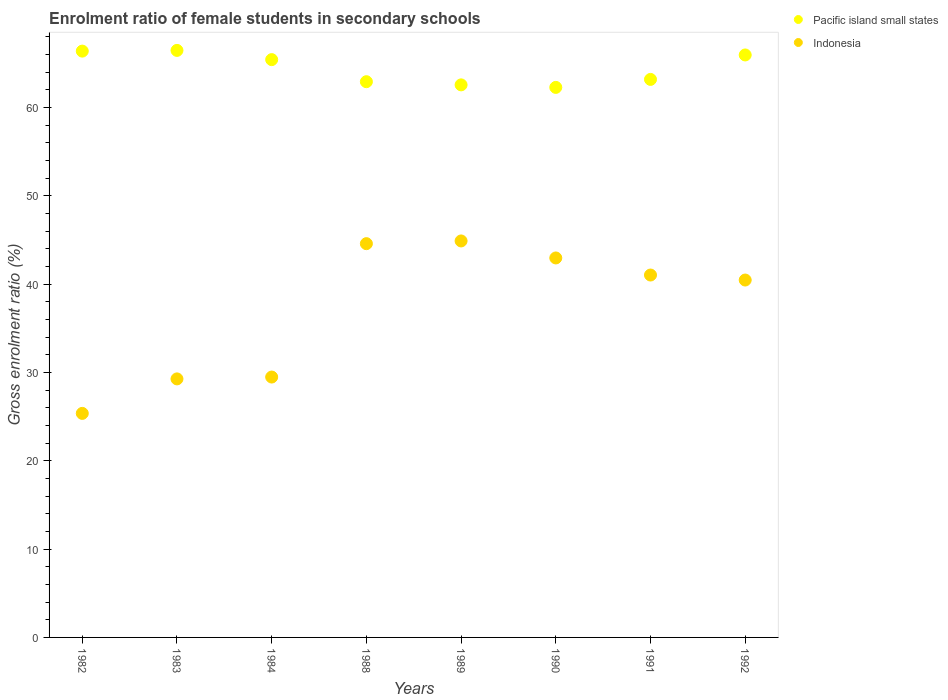How many different coloured dotlines are there?
Your response must be concise. 2. What is the enrolment ratio of female students in secondary schools in Indonesia in 1984?
Keep it short and to the point. 29.48. Across all years, what is the maximum enrolment ratio of female students in secondary schools in Pacific island small states?
Make the answer very short. 66.47. Across all years, what is the minimum enrolment ratio of female students in secondary schools in Pacific island small states?
Your answer should be very brief. 62.28. What is the total enrolment ratio of female students in secondary schools in Indonesia in the graph?
Provide a short and direct response. 298.09. What is the difference between the enrolment ratio of female students in secondary schools in Pacific island small states in 1984 and that in 1992?
Your response must be concise. -0.53. What is the difference between the enrolment ratio of female students in secondary schools in Pacific island small states in 1990 and the enrolment ratio of female students in secondary schools in Indonesia in 1982?
Provide a succinct answer. 36.91. What is the average enrolment ratio of female students in secondary schools in Indonesia per year?
Give a very brief answer. 37.26. In the year 1992, what is the difference between the enrolment ratio of female students in secondary schools in Pacific island small states and enrolment ratio of female students in secondary schools in Indonesia?
Give a very brief answer. 25.49. In how many years, is the enrolment ratio of female students in secondary schools in Indonesia greater than 38 %?
Your response must be concise. 5. What is the ratio of the enrolment ratio of female students in secondary schools in Pacific island small states in 1984 to that in 1989?
Ensure brevity in your answer.  1.05. Is the difference between the enrolment ratio of female students in secondary schools in Pacific island small states in 1990 and 1991 greater than the difference between the enrolment ratio of female students in secondary schools in Indonesia in 1990 and 1991?
Ensure brevity in your answer.  No. What is the difference between the highest and the second highest enrolment ratio of female students in secondary schools in Indonesia?
Ensure brevity in your answer.  0.31. What is the difference between the highest and the lowest enrolment ratio of female students in secondary schools in Pacific island small states?
Offer a very short reply. 4.19. Is the sum of the enrolment ratio of female students in secondary schools in Pacific island small states in 1991 and 1992 greater than the maximum enrolment ratio of female students in secondary schools in Indonesia across all years?
Offer a terse response. Yes. Is the enrolment ratio of female students in secondary schools in Indonesia strictly less than the enrolment ratio of female students in secondary schools in Pacific island small states over the years?
Keep it short and to the point. Yes. How many dotlines are there?
Provide a short and direct response. 2. How many years are there in the graph?
Keep it short and to the point. 8. What is the difference between two consecutive major ticks on the Y-axis?
Offer a very short reply. 10. Does the graph contain grids?
Your response must be concise. No. Where does the legend appear in the graph?
Provide a short and direct response. Top right. How many legend labels are there?
Offer a terse response. 2. What is the title of the graph?
Your answer should be compact. Enrolment ratio of female students in secondary schools. What is the label or title of the X-axis?
Your answer should be very brief. Years. What is the Gross enrolment ratio (%) of Pacific island small states in 1982?
Provide a short and direct response. 66.39. What is the Gross enrolment ratio (%) in Indonesia in 1982?
Your answer should be compact. 25.37. What is the Gross enrolment ratio (%) in Pacific island small states in 1983?
Offer a very short reply. 66.47. What is the Gross enrolment ratio (%) of Indonesia in 1983?
Give a very brief answer. 29.27. What is the Gross enrolment ratio (%) of Pacific island small states in 1984?
Offer a terse response. 65.43. What is the Gross enrolment ratio (%) of Indonesia in 1984?
Provide a short and direct response. 29.48. What is the Gross enrolment ratio (%) of Pacific island small states in 1988?
Offer a terse response. 62.93. What is the Gross enrolment ratio (%) in Indonesia in 1988?
Give a very brief answer. 44.59. What is the Gross enrolment ratio (%) in Pacific island small states in 1989?
Your answer should be compact. 62.57. What is the Gross enrolment ratio (%) in Indonesia in 1989?
Provide a short and direct response. 44.9. What is the Gross enrolment ratio (%) of Pacific island small states in 1990?
Your answer should be compact. 62.28. What is the Gross enrolment ratio (%) in Indonesia in 1990?
Your answer should be compact. 42.97. What is the Gross enrolment ratio (%) of Pacific island small states in 1991?
Provide a short and direct response. 63.19. What is the Gross enrolment ratio (%) of Indonesia in 1991?
Your answer should be very brief. 41.04. What is the Gross enrolment ratio (%) in Pacific island small states in 1992?
Your answer should be very brief. 65.96. What is the Gross enrolment ratio (%) of Indonesia in 1992?
Provide a succinct answer. 40.47. Across all years, what is the maximum Gross enrolment ratio (%) of Pacific island small states?
Keep it short and to the point. 66.47. Across all years, what is the maximum Gross enrolment ratio (%) in Indonesia?
Ensure brevity in your answer.  44.9. Across all years, what is the minimum Gross enrolment ratio (%) of Pacific island small states?
Your answer should be compact. 62.28. Across all years, what is the minimum Gross enrolment ratio (%) in Indonesia?
Provide a succinct answer. 25.37. What is the total Gross enrolment ratio (%) of Pacific island small states in the graph?
Provide a short and direct response. 515.22. What is the total Gross enrolment ratio (%) in Indonesia in the graph?
Offer a terse response. 298.09. What is the difference between the Gross enrolment ratio (%) in Pacific island small states in 1982 and that in 1983?
Ensure brevity in your answer.  -0.08. What is the difference between the Gross enrolment ratio (%) in Indonesia in 1982 and that in 1983?
Offer a very short reply. -3.91. What is the difference between the Gross enrolment ratio (%) in Pacific island small states in 1982 and that in 1984?
Offer a very short reply. 0.96. What is the difference between the Gross enrolment ratio (%) in Indonesia in 1982 and that in 1984?
Make the answer very short. -4.12. What is the difference between the Gross enrolment ratio (%) of Pacific island small states in 1982 and that in 1988?
Make the answer very short. 3.46. What is the difference between the Gross enrolment ratio (%) in Indonesia in 1982 and that in 1988?
Provide a short and direct response. -19.22. What is the difference between the Gross enrolment ratio (%) in Pacific island small states in 1982 and that in 1989?
Make the answer very short. 3.82. What is the difference between the Gross enrolment ratio (%) of Indonesia in 1982 and that in 1989?
Ensure brevity in your answer.  -19.53. What is the difference between the Gross enrolment ratio (%) in Pacific island small states in 1982 and that in 1990?
Provide a succinct answer. 4.11. What is the difference between the Gross enrolment ratio (%) in Indonesia in 1982 and that in 1990?
Give a very brief answer. -17.6. What is the difference between the Gross enrolment ratio (%) of Pacific island small states in 1982 and that in 1991?
Give a very brief answer. 3.2. What is the difference between the Gross enrolment ratio (%) in Indonesia in 1982 and that in 1991?
Keep it short and to the point. -15.67. What is the difference between the Gross enrolment ratio (%) of Pacific island small states in 1982 and that in 1992?
Provide a short and direct response. 0.43. What is the difference between the Gross enrolment ratio (%) in Indonesia in 1982 and that in 1992?
Ensure brevity in your answer.  -15.1. What is the difference between the Gross enrolment ratio (%) of Pacific island small states in 1983 and that in 1984?
Ensure brevity in your answer.  1.04. What is the difference between the Gross enrolment ratio (%) of Indonesia in 1983 and that in 1984?
Your response must be concise. -0.21. What is the difference between the Gross enrolment ratio (%) in Pacific island small states in 1983 and that in 1988?
Offer a terse response. 3.54. What is the difference between the Gross enrolment ratio (%) of Indonesia in 1983 and that in 1988?
Provide a short and direct response. -15.31. What is the difference between the Gross enrolment ratio (%) in Pacific island small states in 1983 and that in 1989?
Provide a succinct answer. 3.9. What is the difference between the Gross enrolment ratio (%) of Indonesia in 1983 and that in 1989?
Your answer should be compact. -15.62. What is the difference between the Gross enrolment ratio (%) of Pacific island small states in 1983 and that in 1990?
Keep it short and to the point. 4.19. What is the difference between the Gross enrolment ratio (%) in Indonesia in 1983 and that in 1990?
Give a very brief answer. -13.7. What is the difference between the Gross enrolment ratio (%) of Pacific island small states in 1983 and that in 1991?
Offer a very short reply. 3.28. What is the difference between the Gross enrolment ratio (%) of Indonesia in 1983 and that in 1991?
Offer a terse response. -11.76. What is the difference between the Gross enrolment ratio (%) of Pacific island small states in 1983 and that in 1992?
Ensure brevity in your answer.  0.52. What is the difference between the Gross enrolment ratio (%) in Indonesia in 1983 and that in 1992?
Your answer should be very brief. -11.19. What is the difference between the Gross enrolment ratio (%) in Pacific island small states in 1984 and that in 1988?
Your response must be concise. 2.5. What is the difference between the Gross enrolment ratio (%) of Indonesia in 1984 and that in 1988?
Ensure brevity in your answer.  -15.1. What is the difference between the Gross enrolment ratio (%) of Pacific island small states in 1984 and that in 1989?
Ensure brevity in your answer.  2.86. What is the difference between the Gross enrolment ratio (%) of Indonesia in 1984 and that in 1989?
Make the answer very short. -15.41. What is the difference between the Gross enrolment ratio (%) in Pacific island small states in 1984 and that in 1990?
Provide a succinct answer. 3.14. What is the difference between the Gross enrolment ratio (%) of Indonesia in 1984 and that in 1990?
Your answer should be very brief. -13.49. What is the difference between the Gross enrolment ratio (%) of Pacific island small states in 1984 and that in 1991?
Give a very brief answer. 2.24. What is the difference between the Gross enrolment ratio (%) of Indonesia in 1984 and that in 1991?
Offer a very short reply. -11.55. What is the difference between the Gross enrolment ratio (%) of Pacific island small states in 1984 and that in 1992?
Keep it short and to the point. -0.53. What is the difference between the Gross enrolment ratio (%) in Indonesia in 1984 and that in 1992?
Your response must be concise. -10.99. What is the difference between the Gross enrolment ratio (%) in Pacific island small states in 1988 and that in 1989?
Keep it short and to the point. 0.36. What is the difference between the Gross enrolment ratio (%) of Indonesia in 1988 and that in 1989?
Make the answer very short. -0.31. What is the difference between the Gross enrolment ratio (%) in Pacific island small states in 1988 and that in 1990?
Your answer should be very brief. 0.64. What is the difference between the Gross enrolment ratio (%) of Indonesia in 1988 and that in 1990?
Your answer should be compact. 1.62. What is the difference between the Gross enrolment ratio (%) in Pacific island small states in 1988 and that in 1991?
Your answer should be compact. -0.26. What is the difference between the Gross enrolment ratio (%) of Indonesia in 1988 and that in 1991?
Your answer should be very brief. 3.55. What is the difference between the Gross enrolment ratio (%) in Pacific island small states in 1988 and that in 1992?
Make the answer very short. -3.03. What is the difference between the Gross enrolment ratio (%) of Indonesia in 1988 and that in 1992?
Make the answer very short. 4.12. What is the difference between the Gross enrolment ratio (%) in Pacific island small states in 1989 and that in 1990?
Offer a very short reply. 0.29. What is the difference between the Gross enrolment ratio (%) in Indonesia in 1989 and that in 1990?
Offer a terse response. 1.93. What is the difference between the Gross enrolment ratio (%) in Pacific island small states in 1989 and that in 1991?
Your response must be concise. -0.62. What is the difference between the Gross enrolment ratio (%) of Indonesia in 1989 and that in 1991?
Offer a terse response. 3.86. What is the difference between the Gross enrolment ratio (%) in Pacific island small states in 1989 and that in 1992?
Your answer should be compact. -3.39. What is the difference between the Gross enrolment ratio (%) of Indonesia in 1989 and that in 1992?
Give a very brief answer. 4.43. What is the difference between the Gross enrolment ratio (%) in Pacific island small states in 1990 and that in 1991?
Your response must be concise. -0.9. What is the difference between the Gross enrolment ratio (%) in Indonesia in 1990 and that in 1991?
Provide a succinct answer. 1.93. What is the difference between the Gross enrolment ratio (%) of Pacific island small states in 1990 and that in 1992?
Keep it short and to the point. -3.67. What is the difference between the Gross enrolment ratio (%) of Indonesia in 1990 and that in 1992?
Provide a succinct answer. 2.5. What is the difference between the Gross enrolment ratio (%) of Pacific island small states in 1991 and that in 1992?
Offer a very short reply. -2.77. What is the difference between the Gross enrolment ratio (%) of Indonesia in 1991 and that in 1992?
Offer a very short reply. 0.57. What is the difference between the Gross enrolment ratio (%) in Pacific island small states in 1982 and the Gross enrolment ratio (%) in Indonesia in 1983?
Your response must be concise. 37.12. What is the difference between the Gross enrolment ratio (%) in Pacific island small states in 1982 and the Gross enrolment ratio (%) in Indonesia in 1984?
Your answer should be very brief. 36.91. What is the difference between the Gross enrolment ratio (%) in Pacific island small states in 1982 and the Gross enrolment ratio (%) in Indonesia in 1988?
Keep it short and to the point. 21.8. What is the difference between the Gross enrolment ratio (%) in Pacific island small states in 1982 and the Gross enrolment ratio (%) in Indonesia in 1989?
Ensure brevity in your answer.  21.5. What is the difference between the Gross enrolment ratio (%) of Pacific island small states in 1982 and the Gross enrolment ratio (%) of Indonesia in 1990?
Provide a succinct answer. 23.42. What is the difference between the Gross enrolment ratio (%) of Pacific island small states in 1982 and the Gross enrolment ratio (%) of Indonesia in 1991?
Give a very brief answer. 25.36. What is the difference between the Gross enrolment ratio (%) in Pacific island small states in 1982 and the Gross enrolment ratio (%) in Indonesia in 1992?
Give a very brief answer. 25.92. What is the difference between the Gross enrolment ratio (%) of Pacific island small states in 1983 and the Gross enrolment ratio (%) of Indonesia in 1984?
Keep it short and to the point. 36.99. What is the difference between the Gross enrolment ratio (%) of Pacific island small states in 1983 and the Gross enrolment ratio (%) of Indonesia in 1988?
Give a very brief answer. 21.88. What is the difference between the Gross enrolment ratio (%) in Pacific island small states in 1983 and the Gross enrolment ratio (%) in Indonesia in 1989?
Offer a very short reply. 21.58. What is the difference between the Gross enrolment ratio (%) in Pacific island small states in 1983 and the Gross enrolment ratio (%) in Indonesia in 1990?
Give a very brief answer. 23.5. What is the difference between the Gross enrolment ratio (%) of Pacific island small states in 1983 and the Gross enrolment ratio (%) of Indonesia in 1991?
Your answer should be very brief. 25.44. What is the difference between the Gross enrolment ratio (%) of Pacific island small states in 1983 and the Gross enrolment ratio (%) of Indonesia in 1992?
Keep it short and to the point. 26. What is the difference between the Gross enrolment ratio (%) in Pacific island small states in 1984 and the Gross enrolment ratio (%) in Indonesia in 1988?
Provide a succinct answer. 20.84. What is the difference between the Gross enrolment ratio (%) of Pacific island small states in 1984 and the Gross enrolment ratio (%) of Indonesia in 1989?
Provide a succinct answer. 20.53. What is the difference between the Gross enrolment ratio (%) of Pacific island small states in 1984 and the Gross enrolment ratio (%) of Indonesia in 1990?
Provide a succinct answer. 22.46. What is the difference between the Gross enrolment ratio (%) of Pacific island small states in 1984 and the Gross enrolment ratio (%) of Indonesia in 1991?
Offer a very short reply. 24.39. What is the difference between the Gross enrolment ratio (%) in Pacific island small states in 1984 and the Gross enrolment ratio (%) in Indonesia in 1992?
Make the answer very short. 24.96. What is the difference between the Gross enrolment ratio (%) in Pacific island small states in 1988 and the Gross enrolment ratio (%) in Indonesia in 1989?
Your response must be concise. 18.03. What is the difference between the Gross enrolment ratio (%) of Pacific island small states in 1988 and the Gross enrolment ratio (%) of Indonesia in 1990?
Your response must be concise. 19.96. What is the difference between the Gross enrolment ratio (%) in Pacific island small states in 1988 and the Gross enrolment ratio (%) in Indonesia in 1991?
Provide a short and direct response. 21.89. What is the difference between the Gross enrolment ratio (%) in Pacific island small states in 1988 and the Gross enrolment ratio (%) in Indonesia in 1992?
Offer a very short reply. 22.46. What is the difference between the Gross enrolment ratio (%) of Pacific island small states in 1989 and the Gross enrolment ratio (%) of Indonesia in 1990?
Your answer should be very brief. 19.6. What is the difference between the Gross enrolment ratio (%) of Pacific island small states in 1989 and the Gross enrolment ratio (%) of Indonesia in 1991?
Offer a very short reply. 21.53. What is the difference between the Gross enrolment ratio (%) of Pacific island small states in 1989 and the Gross enrolment ratio (%) of Indonesia in 1992?
Offer a terse response. 22.1. What is the difference between the Gross enrolment ratio (%) of Pacific island small states in 1990 and the Gross enrolment ratio (%) of Indonesia in 1991?
Give a very brief answer. 21.25. What is the difference between the Gross enrolment ratio (%) of Pacific island small states in 1990 and the Gross enrolment ratio (%) of Indonesia in 1992?
Ensure brevity in your answer.  21.81. What is the difference between the Gross enrolment ratio (%) of Pacific island small states in 1991 and the Gross enrolment ratio (%) of Indonesia in 1992?
Offer a very short reply. 22.72. What is the average Gross enrolment ratio (%) in Pacific island small states per year?
Provide a short and direct response. 64.4. What is the average Gross enrolment ratio (%) in Indonesia per year?
Offer a terse response. 37.26. In the year 1982, what is the difference between the Gross enrolment ratio (%) in Pacific island small states and Gross enrolment ratio (%) in Indonesia?
Your answer should be compact. 41.02. In the year 1983, what is the difference between the Gross enrolment ratio (%) of Pacific island small states and Gross enrolment ratio (%) of Indonesia?
Offer a terse response. 37.2. In the year 1984, what is the difference between the Gross enrolment ratio (%) of Pacific island small states and Gross enrolment ratio (%) of Indonesia?
Make the answer very short. 35.94. In the year 1988, what is the difference between the Gross enrolment ratio (%) in Pacific island small states and Gross enrolment ratio (%) in Indonesia?
Make the answer very short. 18.34. In the year 1989, what is the difference between the Gross enrolment ratio (%) of Pacific island small states and Gross enrolment ratio (%) of Indonesia?
Make the answer very short. 17.67. In the year 1990, what is the difference between the Gross enrolment ratio (%) in Pacific island small states and Gross enrolment ratio (%) in Indonesia?
Offer a very short reply. 19.31. In the year 1991, what is the difference between the Gross enrolment ratio (%) of Pacific island small states and Gross enrolment ratio (%) of Indonesia?
Your answer should be compact. 22.15. In the year 1992, what is the difference between the Gross enrolment ratio (%) of Pacific island small states and Gross enrolment ratio (%) of Indonesia?
Make the answer very short. 25.49. What is the ratio of the Gross enrolment ratio (%) in Pacific island small states in 1982 to that in 1983?
Provide a short and direct response. 1. What is the ratio of the Gross enrolment ratio (%) of Indonesia in 1982 to that in 1983?
Offer a terse response. 0.87. What is the ratio of the Gross enrolment ratio (%) of Pacific island small states in 1982 to that in 1984?
Provide a short and direct response. 1.01. What is the ratio of the Gross enrolment ratio (%) of Indonesia in 1982 to that in 1984?
Your answer should be very brief. 0.86. What is the ratio of the Gross enrolment ratio (%) in Pacific island small states in 1982 to that in 1988?
Provide a short and direct response. 1.05. What is the ratio of the Gross enrolment ratio (%) in Indonesia in 1982 to that in 1988?
Make the answer very short. 0.57. What is the ratio of the Gross enrolment ratio (%) of Pacific island small states in 1982 to that in 1989?
Your answer should be compact. 1.06. What is the ratio of the Gross enrolment ratio (%) in Indonesia in 1982 to that in 1989?
Ensure brevity in your answer.  0.57. What is the ratio of the Gross enrolment ratio (%) in Pacific island small states in 1982 to that in 1990?
Provide a succinct answer. 1.07. What is the ratio of the Gross enrolment ratio (%) of Indonesia in 1982 to that in 1990?
Your response must be concise. 0.59. What is the ratio of the Gross enrolment ratio (%) in Pacific island small states in 1982 to that in 1991?
Ensure brevity in your answer.  1.05. What is the ratio of the Gross enrolment ratio (%) in Indonesia in 1982 to that in 1991?
Your answer should be very brief. 0.62. What is the ratio of the Gross enrolment ratio (%) in Pacific island small states in 1982 to that in 1992?
Ensure brevity in your answer.  1.01. What is the ratio of the Gross enrolment ratio (%) of Indonesia in 1982 to that in 1992?
Your answer should be very brief. 0.63. What is the ratio of the Gross enrolment ratio (%) of Pacific island small states in 1983 to that in 1984?
Offer a very short reply. 1.02. What is the ratio of the Gross enrolment ratio (%) of Indonesia in 1983 to that in 1984?
Your response must be concise. 0.99. What is the ratio of the Gross enrolment ratio (%) of Pacific island small states in 1983 to that in 1988?
Ensure brevity in your answer.  1.06. What is the ratio of the Gross enrolment ratio (%) of Indonesia in 1983 to that in 1988?
Your answer should be very brief. 0.66. What is the ratio of the Gross enrolment ratio (%) of Pacific island small states in 1983 to that in 1989?
Your answer should be very brief. 1.06. What is the ratio of the Gross enrolment ratio (%) in Indonesia in 1983 to that in 1989?
Ensure brevity in your answer.  0.65. What is the ratio of the Gross enrolment ratio (%) in Pacific island small states in 1983 to that in 1990?
Offer a terse response. 1.07. What is the ratio of the Gross enrolment ratio (%) of Indonesia in 1983 to that in 1990?
Ensure brevity in your answer.  0.68. What is the ratio of the Gross enrolment ratio (%) of Pacific island small states in 1983 to that in 1991?
Offer a terse response. 1.05. What is the ratio of the Gross enrolment ratio (%) of Indonesia in 1983 to that in 1991?
Your answer should be very brief. 0.71. What is the ratio of the Gross enrolment ratio (%) in Pacific island small states in 1983 to that in 1992?
Provide a succinct answer. 1.01. What is the ratio of the Gross enrolment ratio (%) of Indonesia in 1983 to that in 1992?
Provide a succinct answer. 0.72. What is the ratio of the Gross enrolment ratio (%) of Pacific island small states in 1984 to that in 1988?
Your response must be concise. 1.04. What is the ratio of the Gross enrolment ratio (%) in Indonesia in 1984 to that in 1988?
Make the answer very short. 0.66. What is the ratio of the Gross enrolment ratio (%) in Pacific island small states in 1984 to that in 1989?
Your answer should be very brief. 1.05. What is the ratio of the Gross enrolment ratio (%) in Indonesia in 1984 to that in 1989?
Provide a short and direct response. 0.66. What is the ratio of the Gross enrolment ratio (%) in Pacific island small states in 1984 to that in 1990?
Make the answer very short. 1.05. What is the ratio of the Gross enrolment ratio (%) of Indonesia in 1984 to that in 1990?
Make the answer very short. 0.69. What is the ratio of the Gross enrolment ratio (%) in Pacific island small states in 1984 to that in 1991?
Ensure brevity in your answer.  1.04. What is the ratio of the Gross enrolment ratio (%) of Indonesia in 1984 to that in 1991?
Provide a succinct answer. 0.72. What is the ratio of the Gross enrolment ratio (%) of Pacific island small states in 1984 to that in 1992?
Make the answer very short. 0.99. What is the ratio of the Gross enrolment ratio (%) in Indonesia in 1984 to that in 1992?
Give a very brief answer. 0.73. What is the ratio of the Gross enrolment ratio (%) in Pacific island small states in 1988 to that in 1989?
Keep it short and to the point. 1.01. What is the ratio of the Gross enrolment ratio (%) in Pacific island small states in 1988 to that in 1990?
Offer a very short reply. 1.01. What is the ratio of the Gross enrolment ratio (%) in Indonesia in 1988 to that in 1990?
Ensure brevity in your answer.  1.04. What is the ratio of the Gross enrolment ratio (%) in Pacific island small states in 1988 to that in 1991?
Your answer should be compact. 1. What is the ratio of the Gross enrolment ratio (%) in Indonesia in 1988 to that in 1991?
Your answer should be compact. 1.09. What is the ratio of the Gross enrolment ratio (%) of Pacific island small states in 1988 to that in 1992?
Your response must be concise. 0.95. What is the ratio of the Gross enrolment ratio (%) in Indonesia in 1988 to that in 1992?
Give a very brief answer. 1.1. What is the ratio of the Gross enrolment ratio (%) of Pacific island small states in 1989 to that in 1990?
Keep it short and to the point. 1. What is the ratio of the Gross enrolment ratio (%) in Indonesia in 1989 to that in 1990?
Provide a succinct answer. 1.04. What is the ratio of the Gross enrolment ratio (%) in Pacific island small states in 1989 to that in 1991?
Provide a succinct answer. 0.99. What is the ratio of the Gross enrolment ratio (%) in Indonesia in 1989 to that in 1991?
Your answer should be compact. 1.09. What is the ratio of the Gross enrolment ratio (%) in Pacific island small states in 1989 to that in 1992?
Provide a succinct answer. 0.95. What is the ratio of the Gross enrolment ratio (%) of Indonesia in 1989 to that in 1992?
Your response must be concise. 1.11. What is the ratio of the Gross enrolment ratio (%) in Pacific island small states in 1990 to that in 1991?
Provide a short and direct response. 0.99. What is the ratio of the Gross enrolment ratio (%) of Indonesia in 1990 to that in 1991?
Your answer should be very brief. 1.05. What is the ratio of the Gross enrolment ratio (%) of Pacific island small states in 1990 to that in 1992?
Offer a terse response. 0.94. What is the ratio of the Gross enrolment ratio (%) of Indonesia in 1990 to that in 1992?
Make the answer very short. 1.06. What is the ratio of the Gross enrolment ratio (%) of Pacific island small states in 1991 to that in 1992?
Offer a very short reply. 0.96. What is the ratio of the Gross enrolment ratio (%) in Indonesia in 1991 to that in 1992?
Your answer should be compact. 1.01. What is the difference between the highest and the second highest Gross enrolment ratio (%) in Pacific island small states?
Offer a very short reply. 0.08. What is the difference between the highest and the second highest Gross enrolment ratio (%) of Indonesia?
Offer a very short reply. 0.31. What is the difference between the highest and the lowest Gross enrolment ratio (%) in Pacific island small states?
Offer a very short reply. 4.19. What is the difference between the highest and the lowest Gross enrolment ratio (%) of Indonesia?
Make the answer very short. 19.53. 